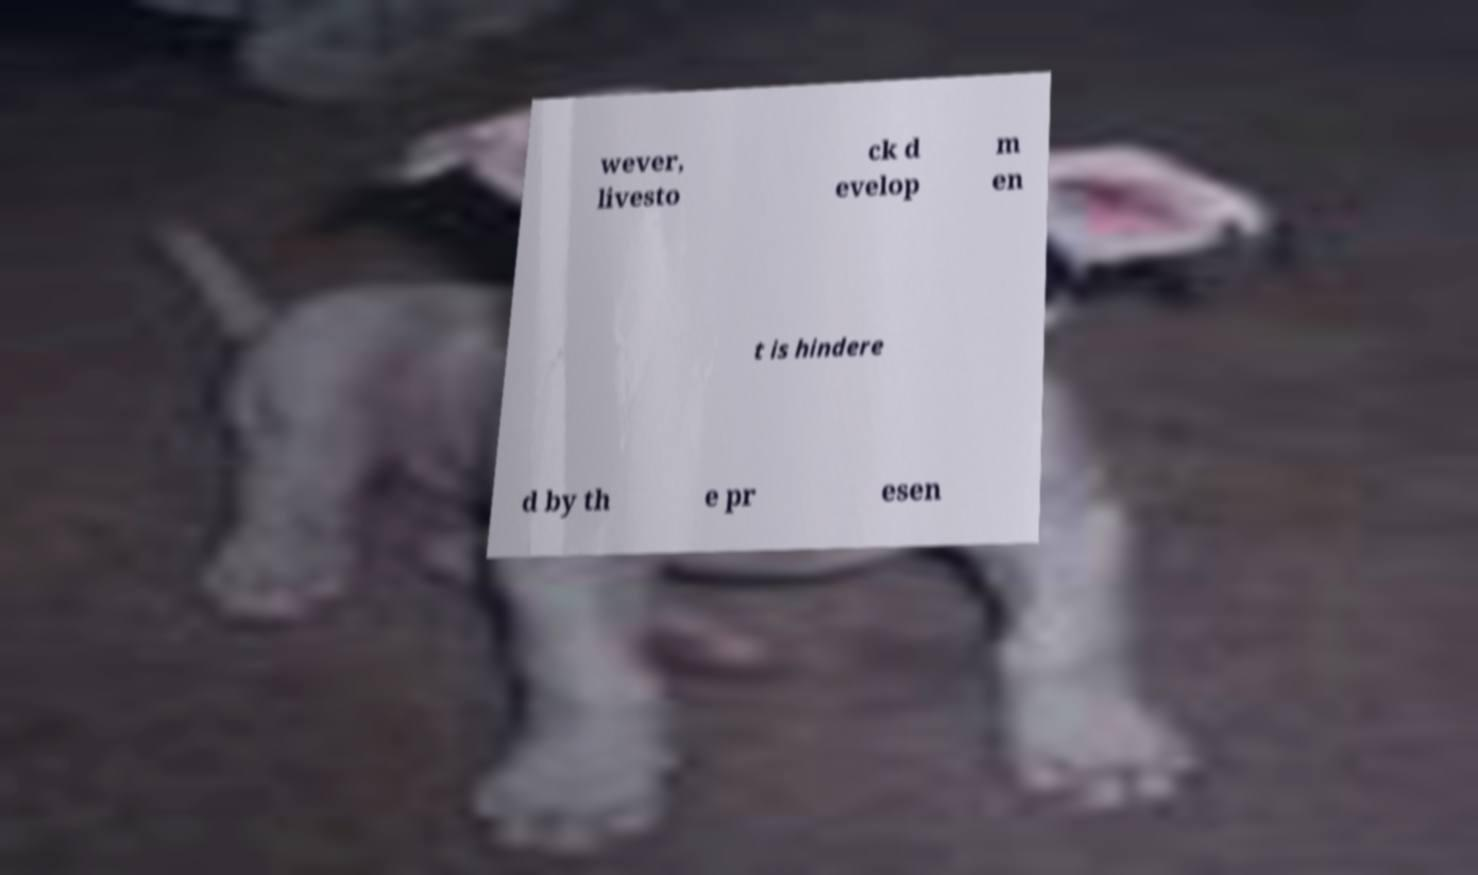Please read and relay the text visible in this image. What does it say? wever, livesto ck d evelop m en t is hindere d by th e pr esen 